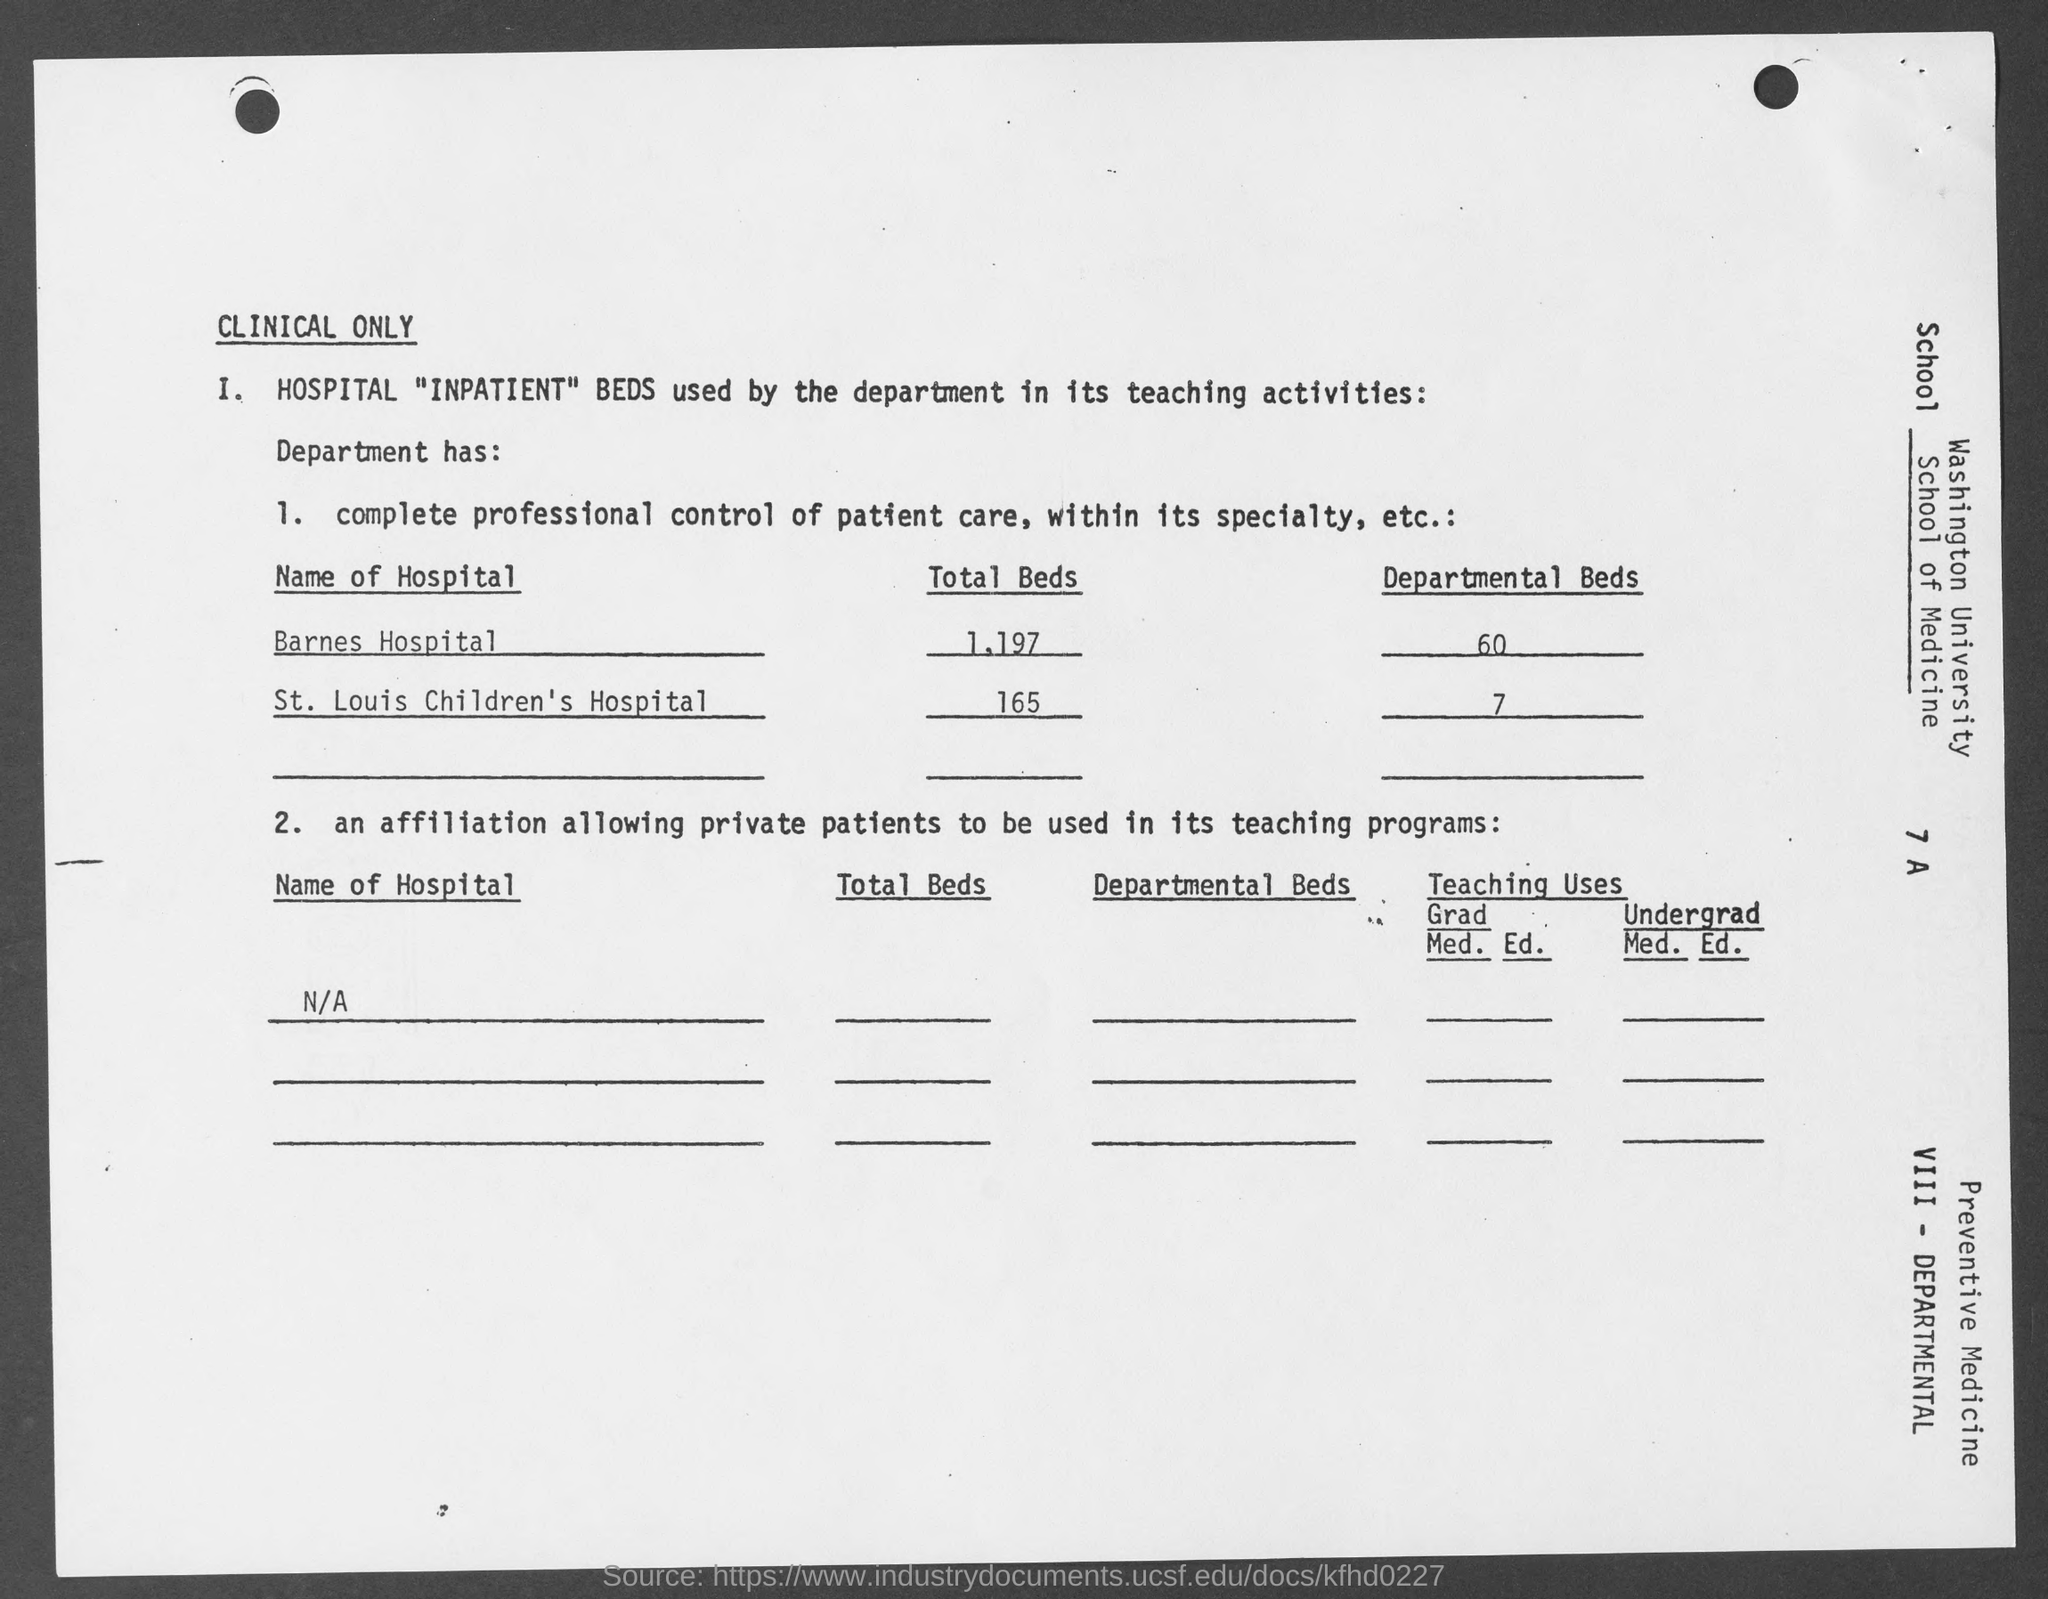What is the total beds in barnes hospital ?
Make the answer very short. 1,197. How many departmental beds are there in barnes hospital?
Ensure brevity in your answer.  60. What is the total beds in st. louis children's hospital ?
Keep it short and to the point. 165. How many departmental beds are there in st. louis children's hospital ?
Your response must be concise. 7. 